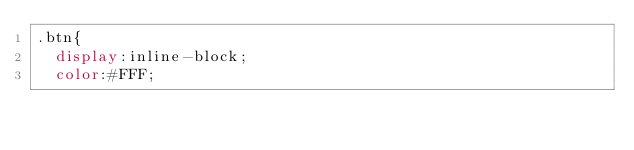<code> <loc_0><loc_0><loc_500><loc_500><_CSS_>.btn{
  display:inline-block;
  color:#FFF;</code> 